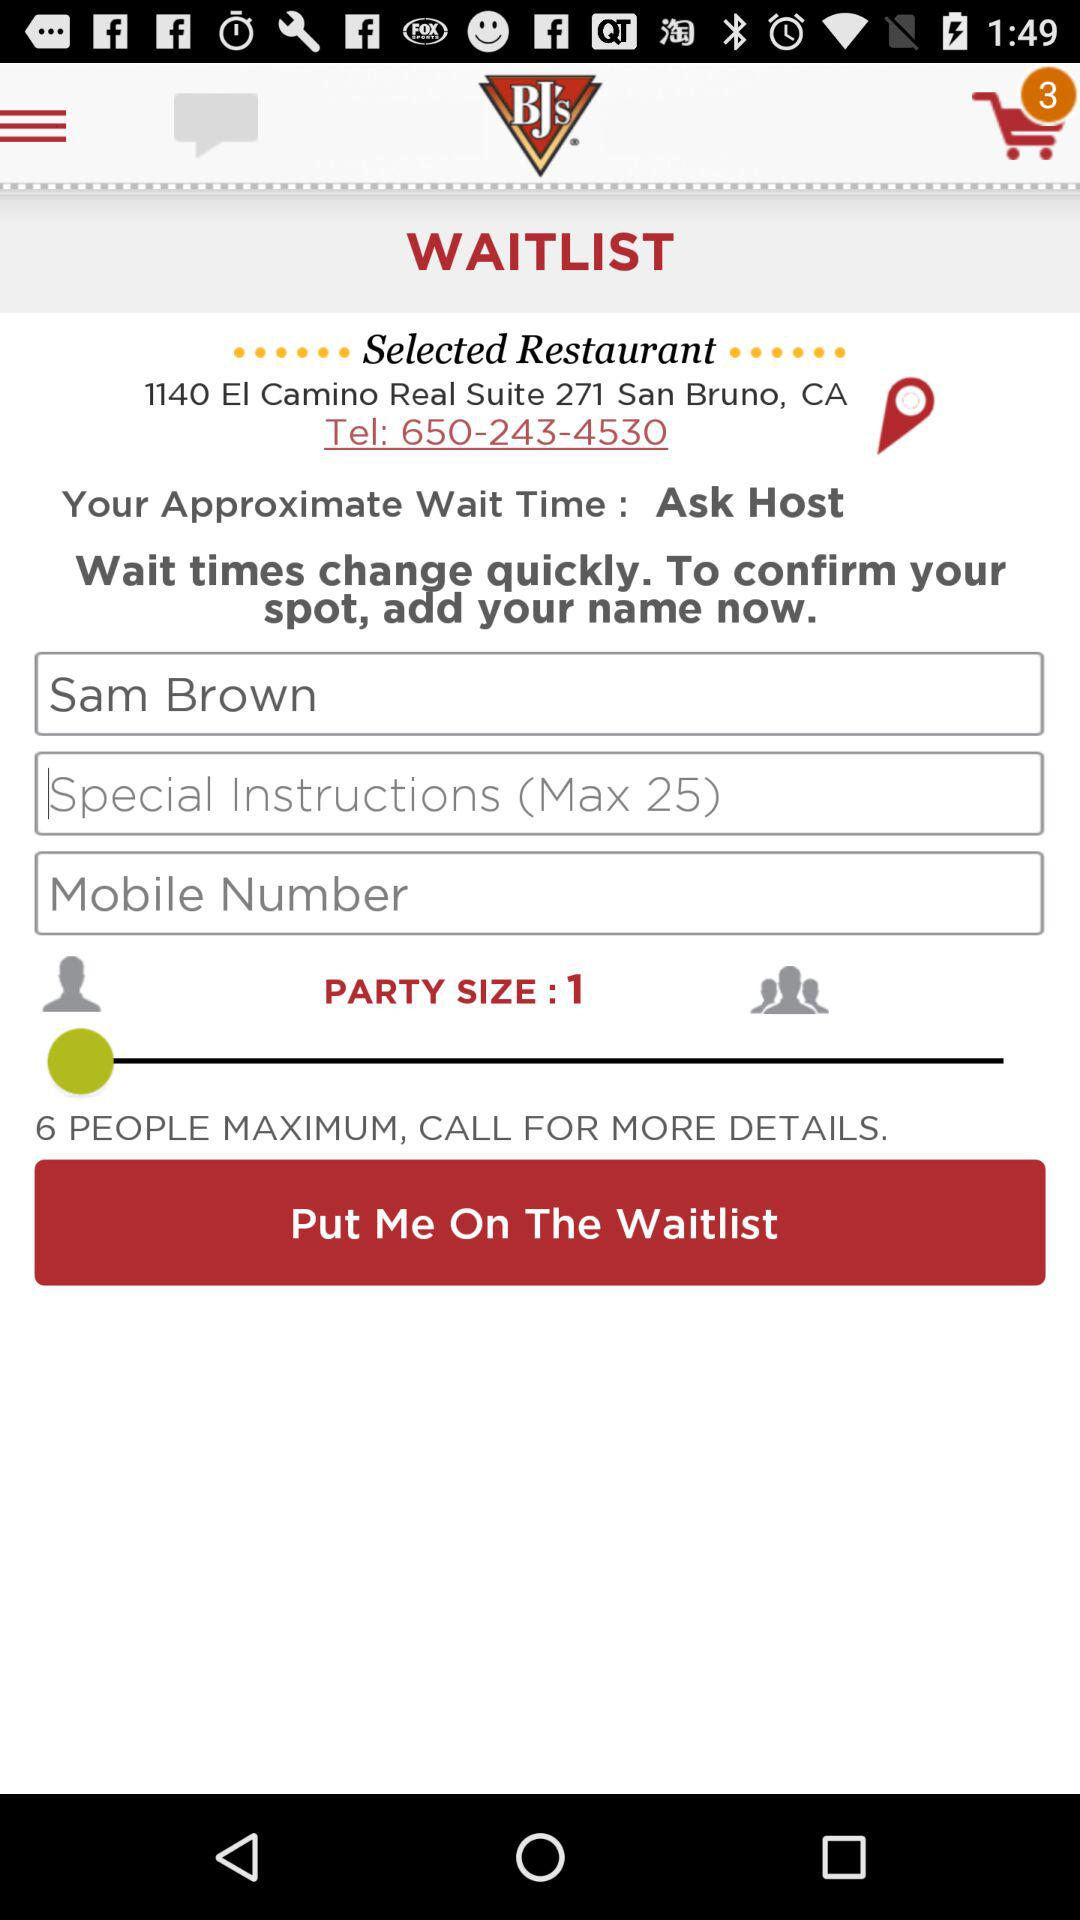What is the party size? The party size is 1. 